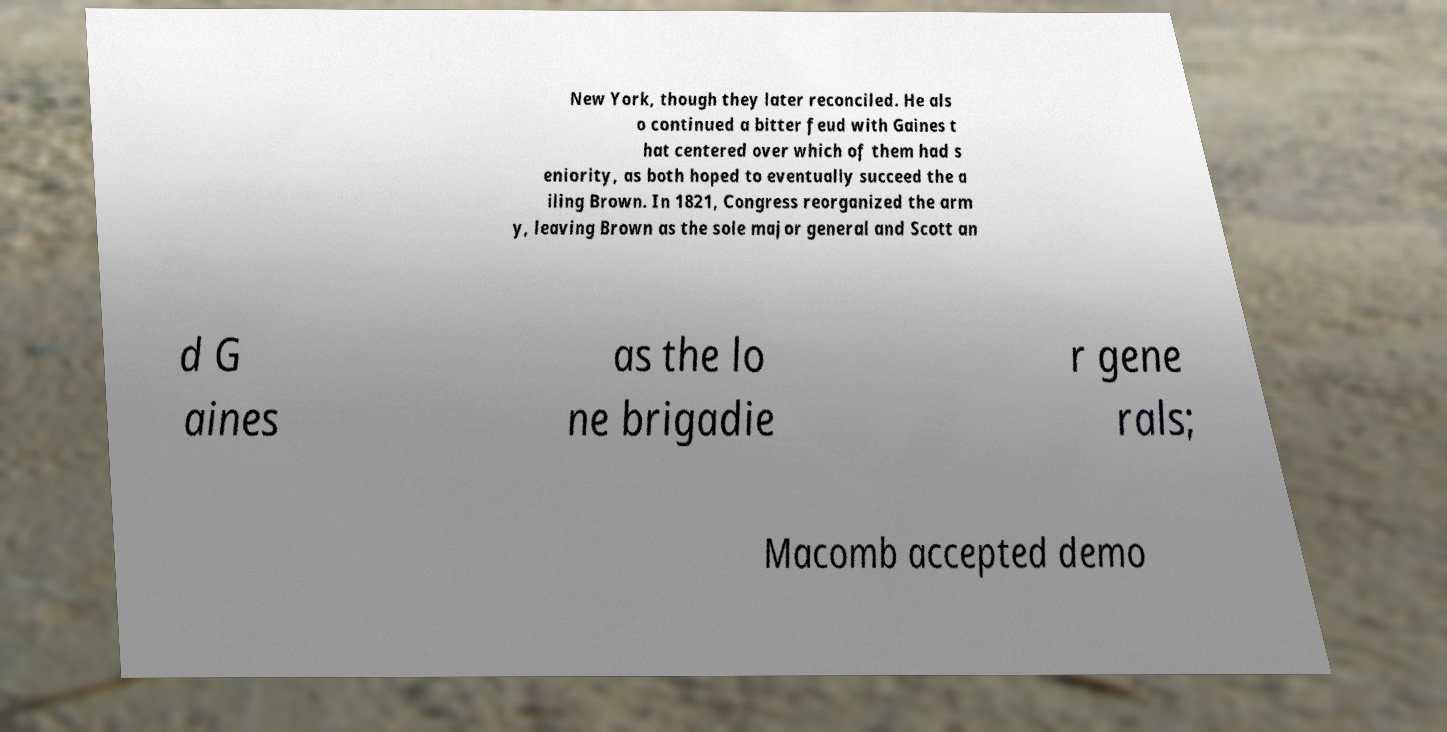What messages or text are displayed in this image? I need them in a readable, typed format. New York, though they later reconciled. He als o continued a bitter feud with Gaines t hat centered over which of them had s eniority, as both hoped to eventually succeed the a iling Brown. In 1821, Congress reorganized the arm y, leaving Brown as the sole major general and Scott an d G aines as the lo ne brigadie r gene rals; Macomb accepted demo 